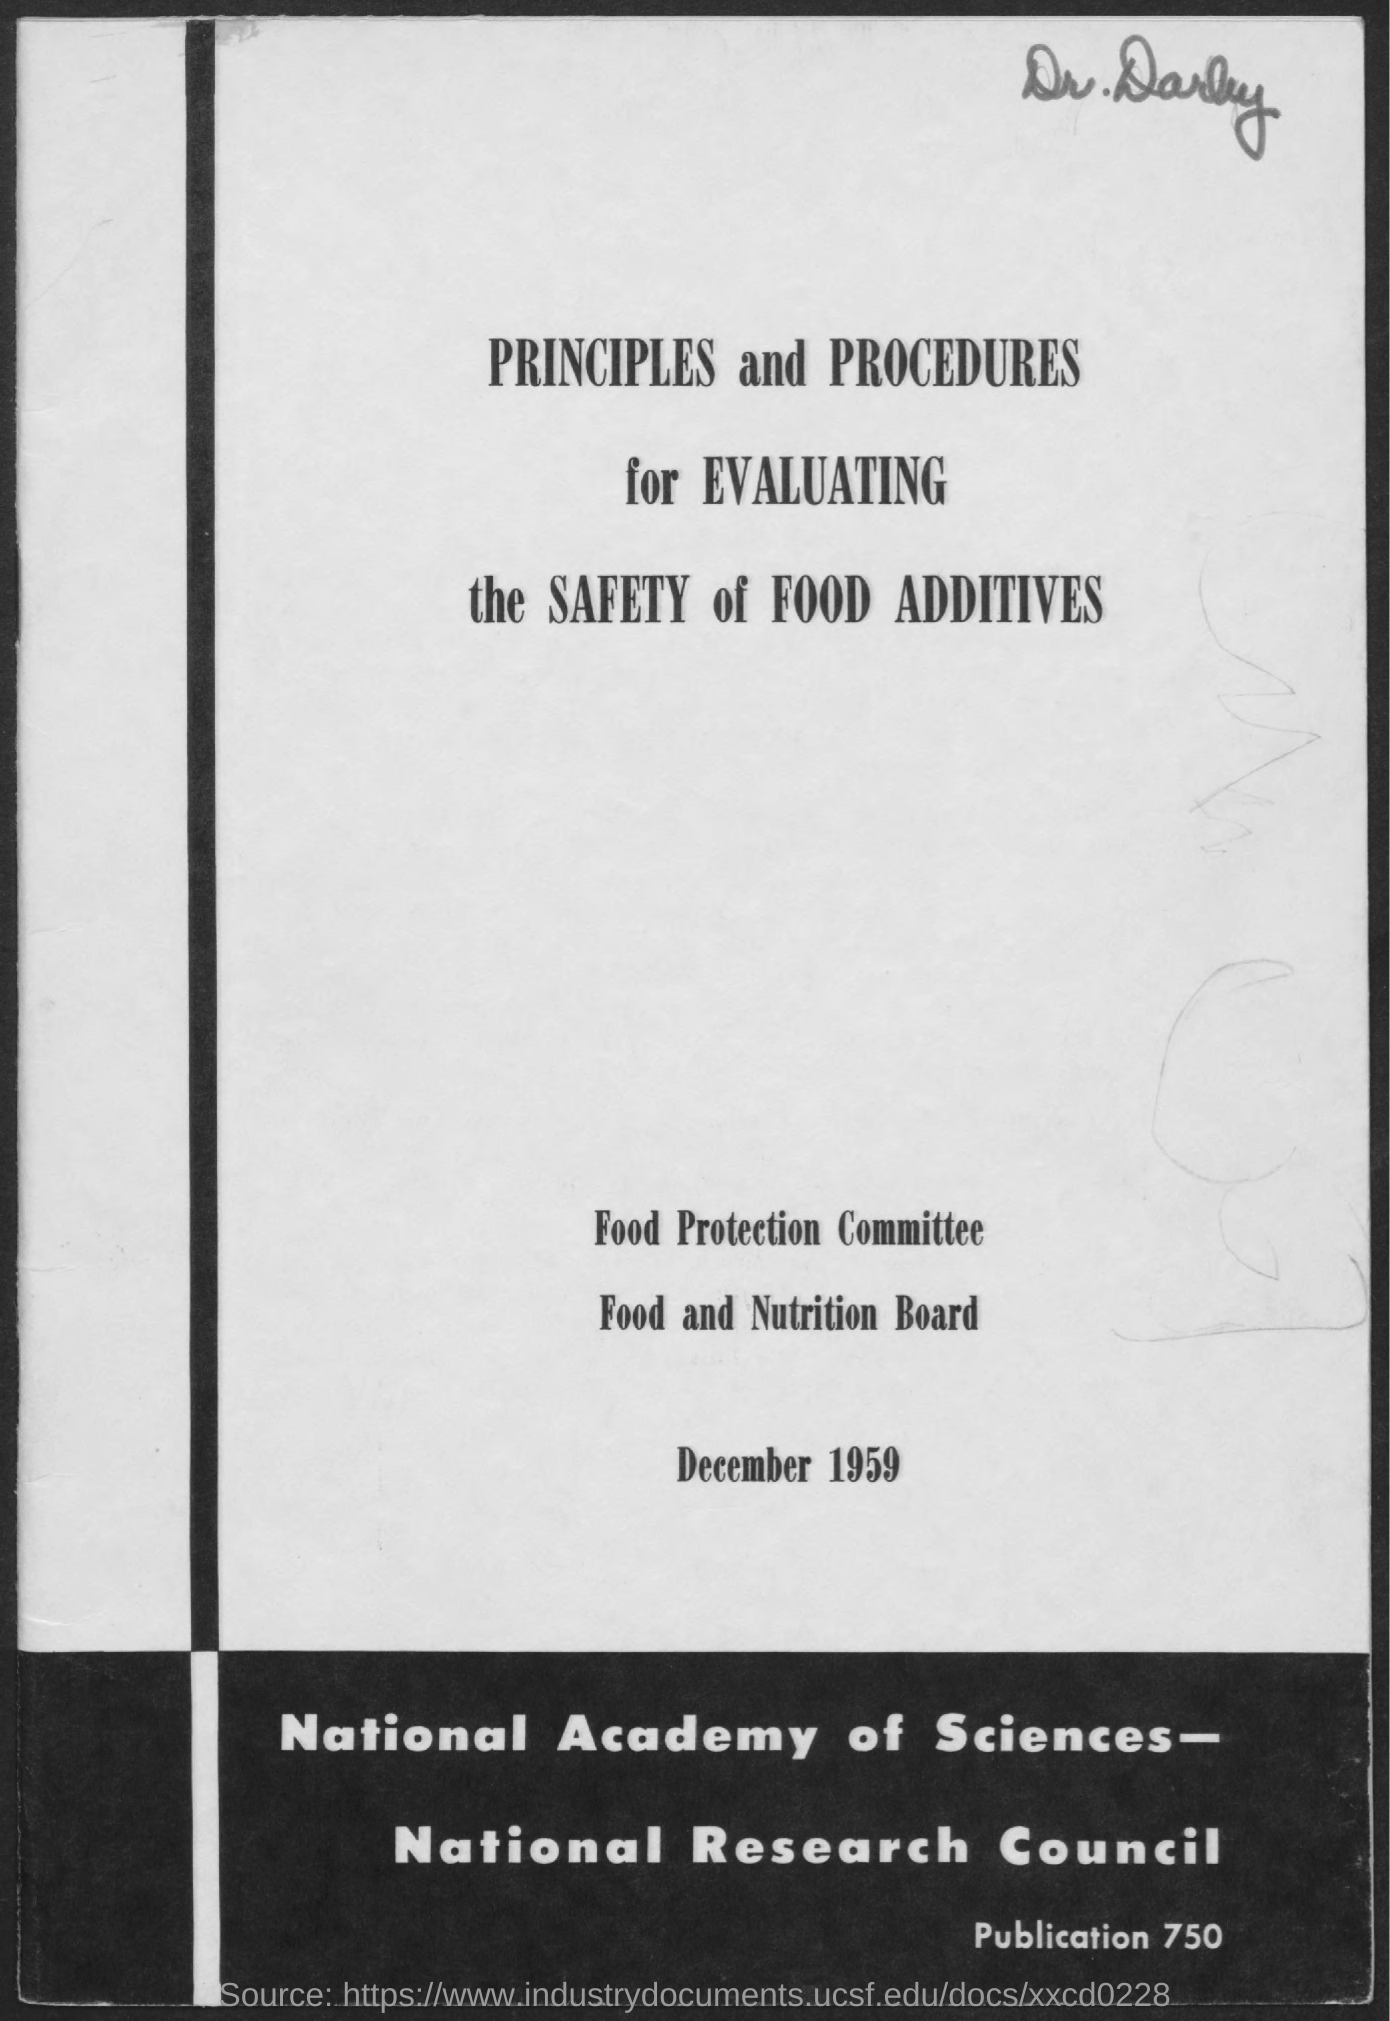Highlight a few significant elements in this photo. The document mentions a date of December 1959. The name of the doctor written at the top right of the document is Darby. The Food Protection Committee is the name of the committee mentioned in the document. 